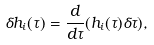<formula> <loc_0><loc_0><loc_500><loc_500>\delta h _ { i } ( \tau ) = \frac { d } { d \tau } ( h _ { i } ( \tau ) \delta \tau ) ,</formula> 